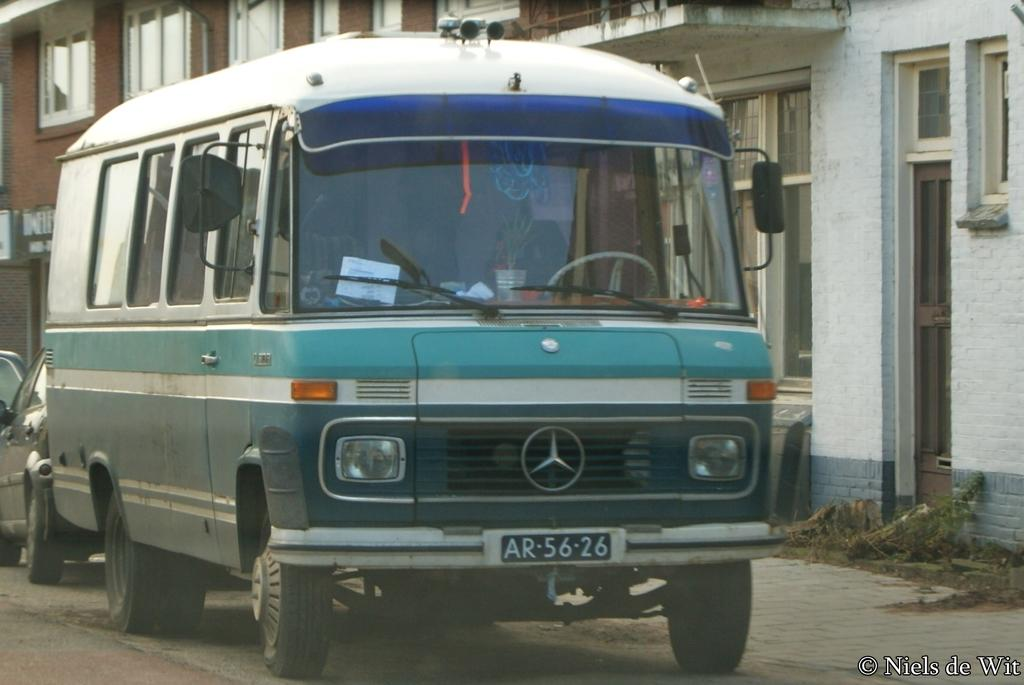What type of structures are visible in the image? There are buildings with windows in the image. What else can be seen in the image besides the buildings? There are vehicles in the image. Is there any text present in the image? Yes, there is some text at the bottom on the left-hand side of the image. Where is the orange brush located in the image? There is no orange brush present in the image. 